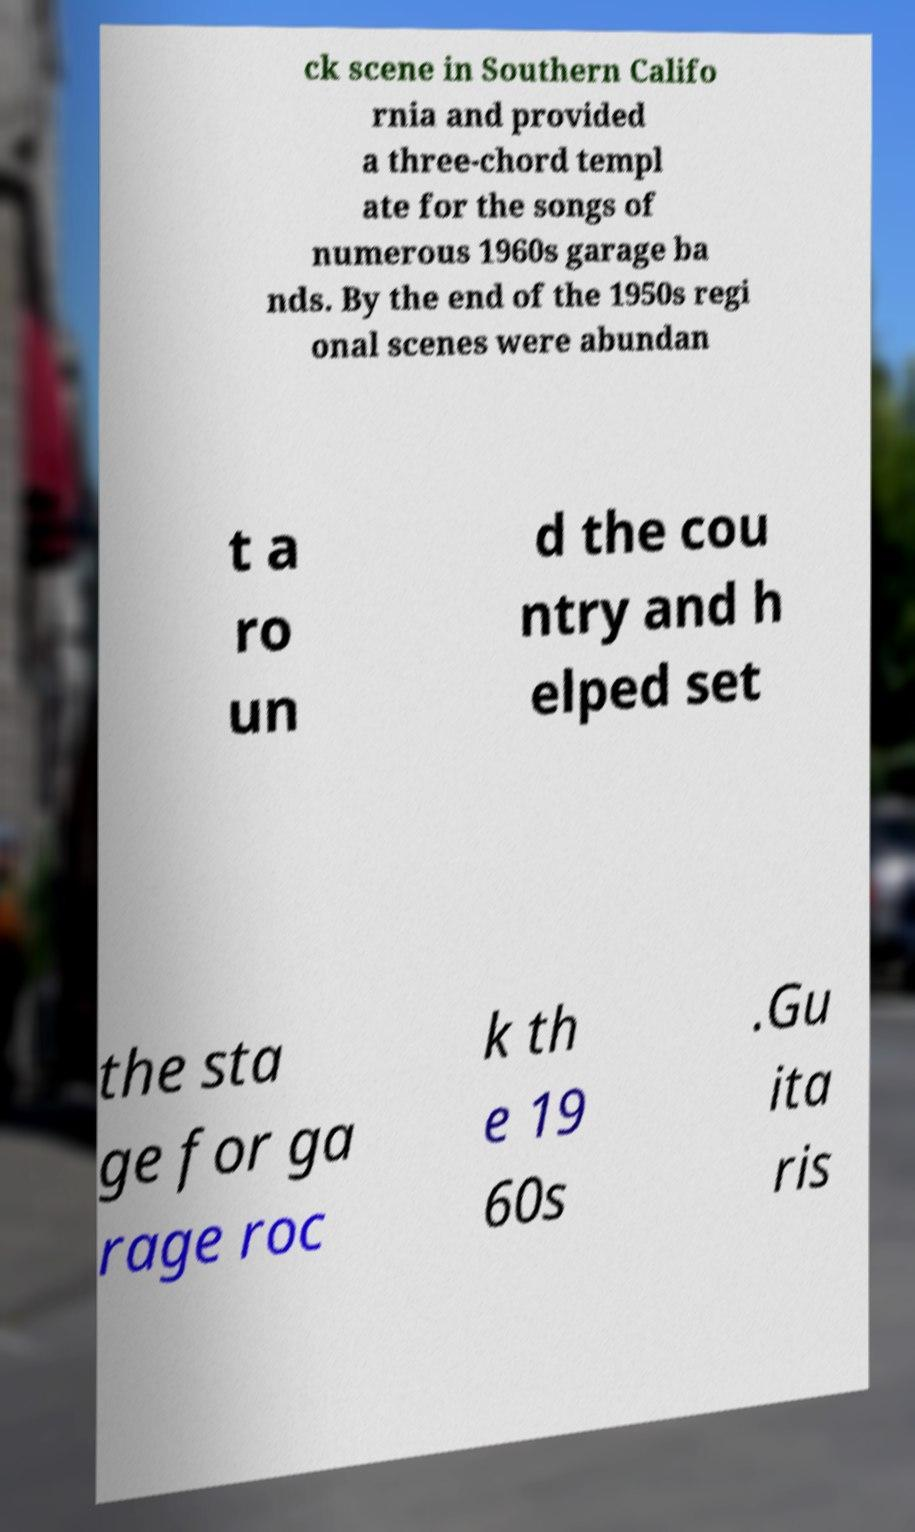Could you assist in decoding the text presented in this image and type it out clearly? ck scene in Southern Califo rnia and provided a three-chord templ ate for the songs of numerous 1960s garage ba nds. By the end of the 1950s regi onal scenes were abundan t a ro un d the cou ntry and h elped set the sta ge for ga rage roc k th e 19 60s .Gu ita ris 